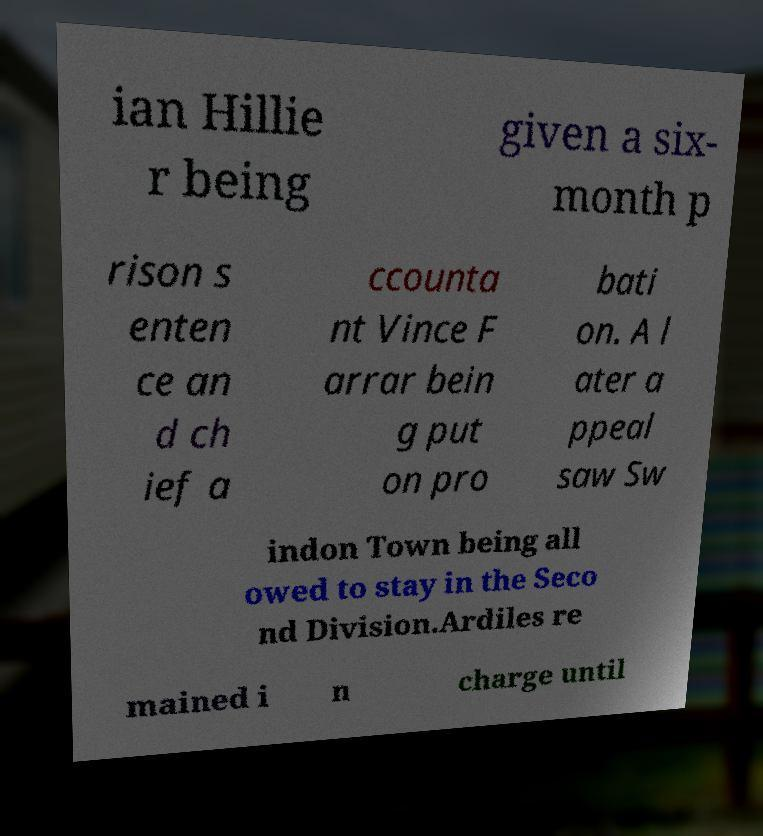Can you read and provide the text displayed in the image?This photo seems to have some interesting text. Can you extract and type it out for me? ian Hillie r being given a six- month p rison s enten ce an d ch ief a ccounta nt Vince F arrar bein g put on pro bati on. A l ater a ppeal saw Sw indon Town being all owed to stay in the Seco nd Division.Ardiles re mained i n charge until 